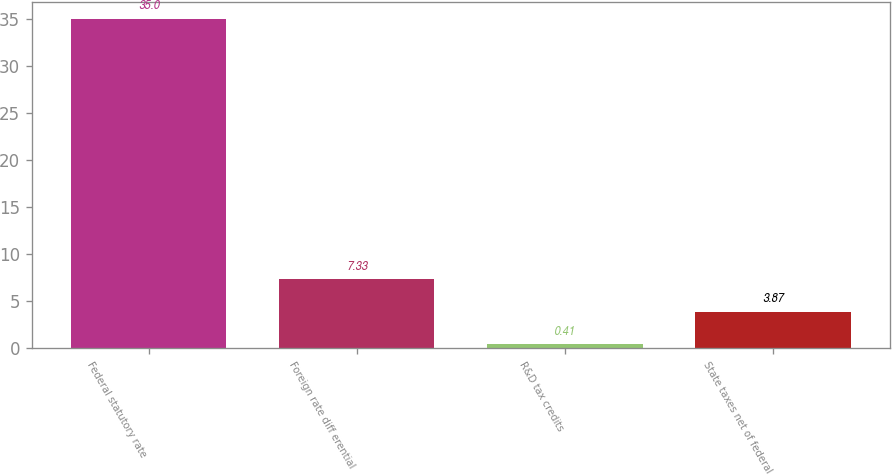Convert chart to OTSL. <chart><loc_0><loc_0><loc_500><loc_500><bar_chart><fcel>Federal statutory rate<fcel>Foreign rate diff erential<fcel>R&D tax credits<fcel>State taxes net of federal<nl><fcel>35<fcel>7.33<fcel>0.41<fcel>3.87<nl></chart> 